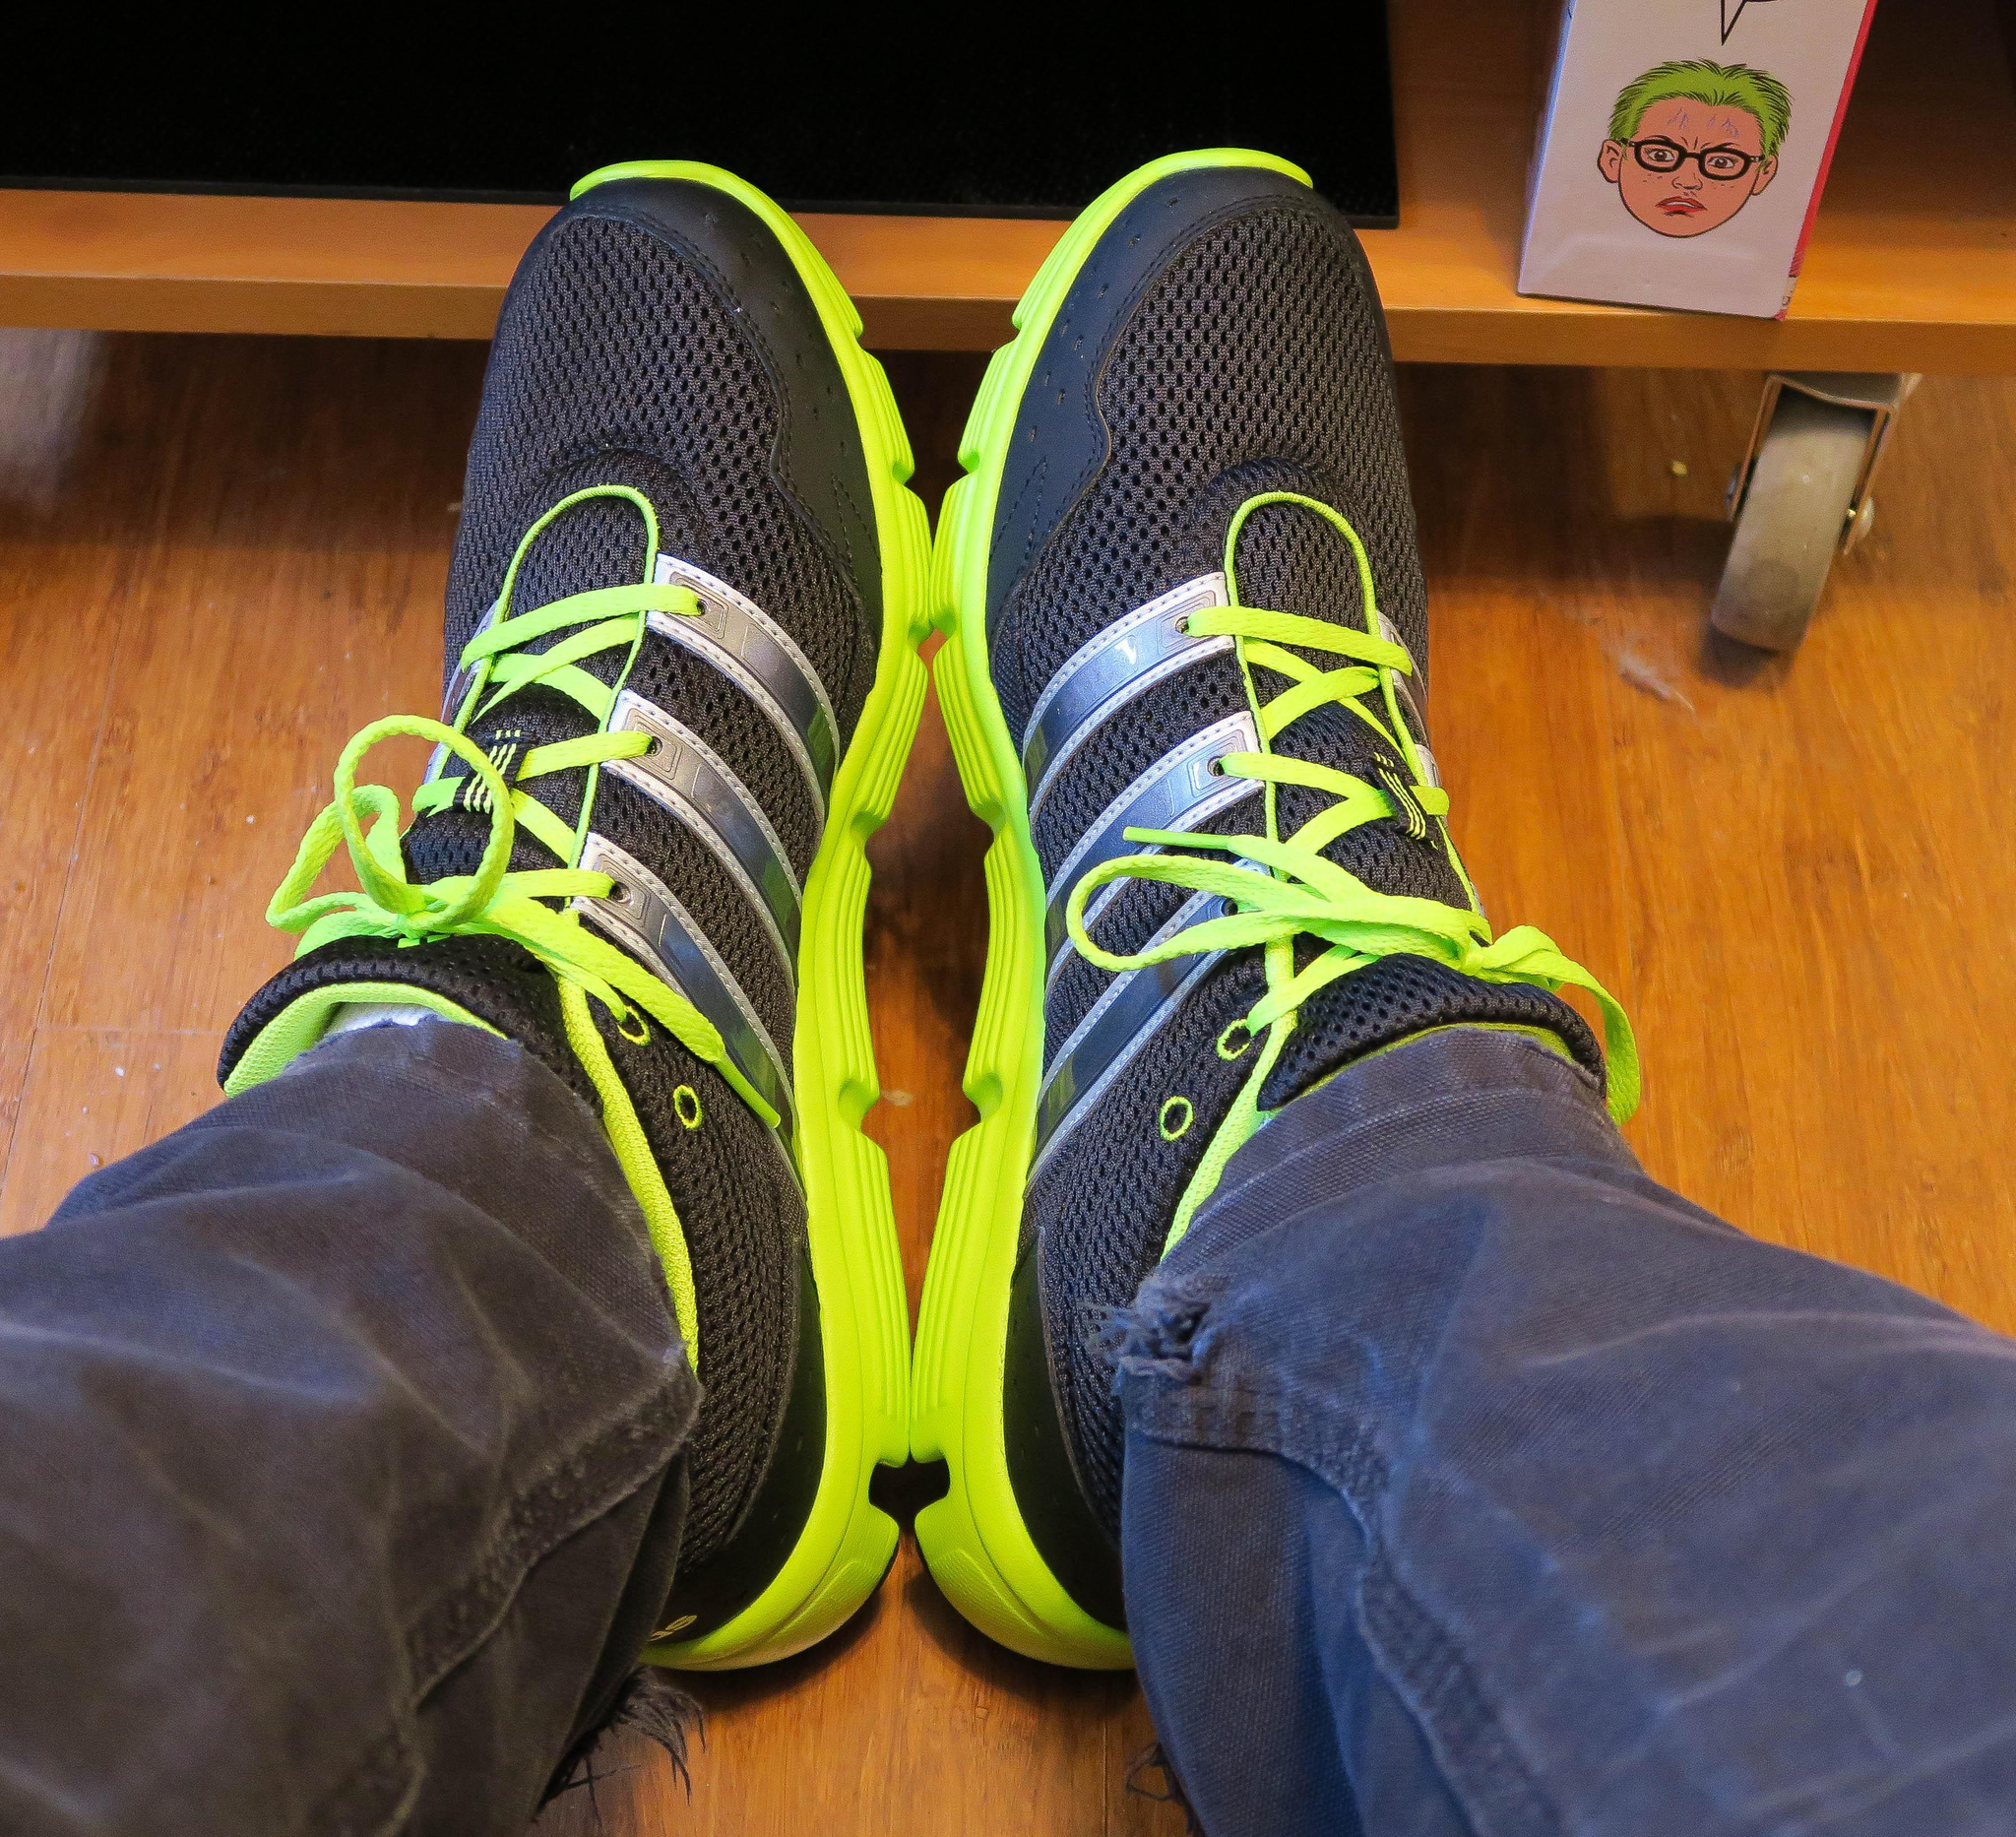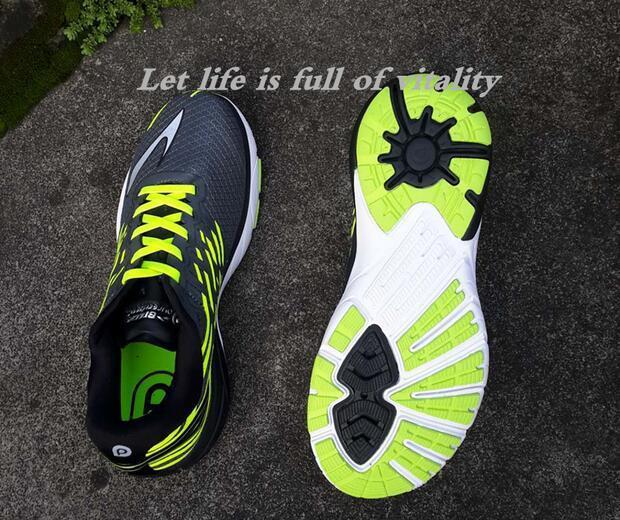The first image is the image on the left, the second image is the image on the right. Examine the images to the left and right. Is the description "In total, no more than five individual shoes are shown." accurate? Answer yes or no. Yes. 